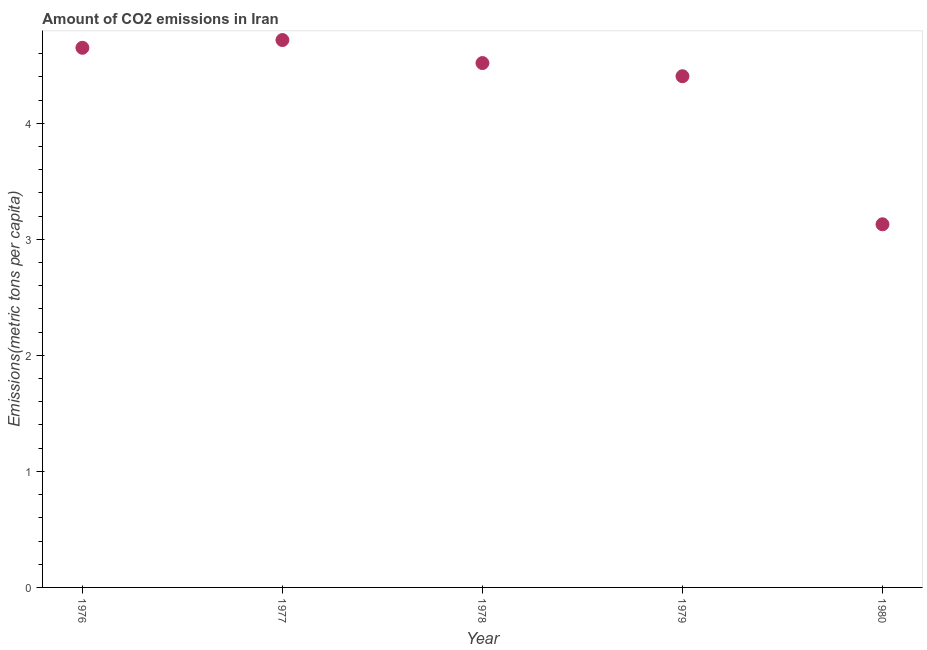What is the amount of co2 emissions in 1977?
Keep it short and to the point. 4.72. Across all years, what is the maximum amount of co2 emissions?
Offer a terse response. 4.72. Across all years, what is the minimum amount of co2 emissions?
Offer a very short reply. 3.13. What is the sum of the amount of co2 emissions?
Give a very brief answer. 21.42. What is the difference between the amount of co2 emissions in 1978 and 1980?
Your answer should be very brief. 1.39. What is the average amount of co2 emissions per year?
Your response must be concise. 4.28. What is the median amount of co2 emissions?
Offer a terse response. 4.52. What is the ratio of the amount of co2 emissions in 1979 to that in 1980?
Your answer should be very brief. 1.41. Is the difference between the amount of co2 emissions in 1979 and 1980 greater than the difference between any two years?
Your answer should be compact. No. What is the difference between the highest and the second highest amount of co2 emissions?
Provide a short and direct response. 0.07. Is the sum of the amount of co2 emissions in 1976 and 1980 greater than the maximum amount of co2 emissions across all years?
Your answer should be very brief. Yes. What is the difference between the highest and the lowest amount of co2 emissions?
Your response must be concise. 1.59. How many dotlines are there?
Provide a succinct answer. 1. Does the graph contain any zero values?
Your response must be concise. No. What is the title of the graph?
Your answer should be compact. Amount of CO2 emissions in Iran. What is the label or title of the X-axis?
Offer a terse response. Year. What is the label or title of the Y-axis?
Your response must be concise. Emissions(metric tons per capita). What is the Emissions(metric tons per capita) in 1976?
Provide a succinct answer. 4.65. What is the Emissions(metric tons per capita) in 1977?
Offer a terse response. 4.72. What is the Emissions(metric tons per capita) in 1978?
Your answer should be compact. 4.52. What is the Emissions(metric tons per capita) in 1979?
Offer a terse response. 4.41. What is the Emissions(metric tons per capita) in 1980?
Your answer should be compact. 3.13. What is the difference between the Emissions(metric tons per capita) in 1976 and 1977?
Your answer should be compact. -0.07. What is the difference between the Emissions(metric tons per capita) in 1976 and 1978?
Offer a terse response. 0.13. What is the difference between the Emissions(metric tons per capita) in 1976 and 1979?
Provide a succinct answer. 0.25. What is the difference between the Emissions(metric tons per capita) in 1976 and 1980?
Keep it short and to the point. 1.52. What is the difference between the Emissions(metric tons per capita) in 1977 and 1978?
Offer a very short reply. 0.2. What is the difference between the Emissions(metric tons per capita) in 1977 and 1979?
Provide a succinct answer. 0.31. What is the difference between the Emissions(metric tons per capita) in 1977 and 1980?
Your answer should be compact. 1.59. What is the difference between the Emissions(metric tons per capita) in 1978 and 1979?
Provide a succinct answer. 0.11. What is the difference between the Emissions(metric tons per capita) in 1978 and 1980?
Provide a short and direct response. 1.39. What is the difference between the Emissions(metric tons per capita) in 1979 and 1980?
Ensure brevity in your answer.  1.28. What is the ratio of the Emissions(metric tons per capita) in 1976 to that in 1977?
Ensure brevity in your answer.  0.99. What is the ratio of the Emissions(metric tons per capita) in 1976 to that in 1978?
Offer a very short reply. 1.03. What is the ratio of the Emissions(metric tons per capita) in 1976 to that in 1979?
Ensure brevity in your answer.  1.06. What is the ratio of the Emissions(metric tons per capita) in 1976 to that in 1980?
Provide a succinct answer. 1.49. What is the ratio of the Emissions(metric tons per capita) in 1977 to that in 1978?
Your answer should be compact. 1.04. What is the ratio of the Emissions(metric tons per capita) in 1977 to that in 1979?
Your answer should be compact. 1.07. What is the ratio of the Emissions(metric tons per capita) in 1977 to that in 1980?
Keep it short and to the point. 1.51. What is the ratio of the Emissions(metric tons per capita) in 1978 to that in 1980?
Your answer should be very brief. 1.44. What is the ratio of the Emissions(metric tons per capita) in 1979 to that in 1980?
Make the answer very short. 1.41. 